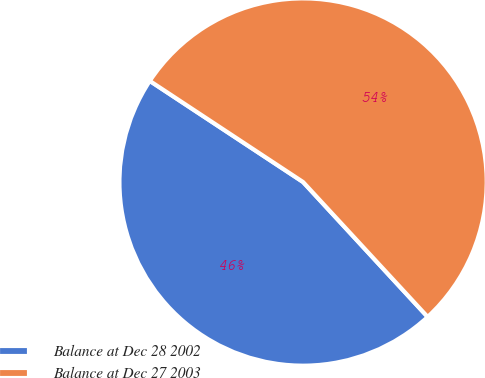Convert chart to OTSL. <chart><loc_0><loc_0><loc_500><loc_500><pie_chart><fcel>Balance at Dec 28 2002<fcel>Balance at Dec 27 2003<nl><fcel>46.15%<fcel>53.85%<nl></chart> 